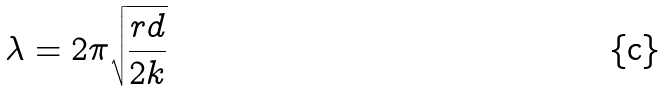Convert formula to latex. <formula><loc_0><loc_0><loc_500><loc_500>\lambda = 2 \pi \sqrt { \frac { r d } { 2 k } }</formula> 